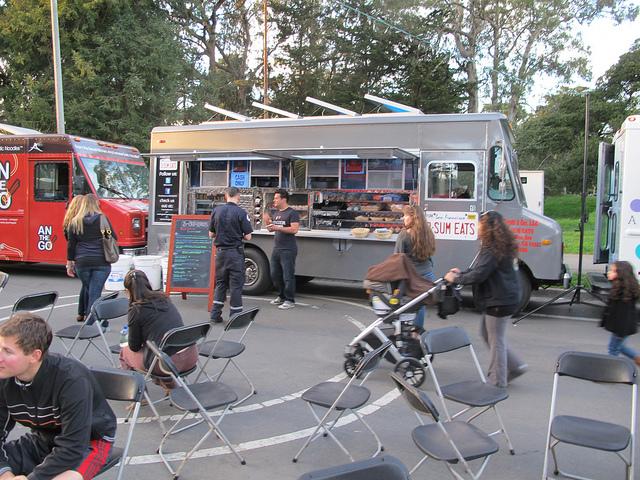How many autos are there?
Keep it brief. 3. How many people are occupying chairs in this picture?
Answer briefly. 2. What type of truck is this?
Write a very short answer. Food. 